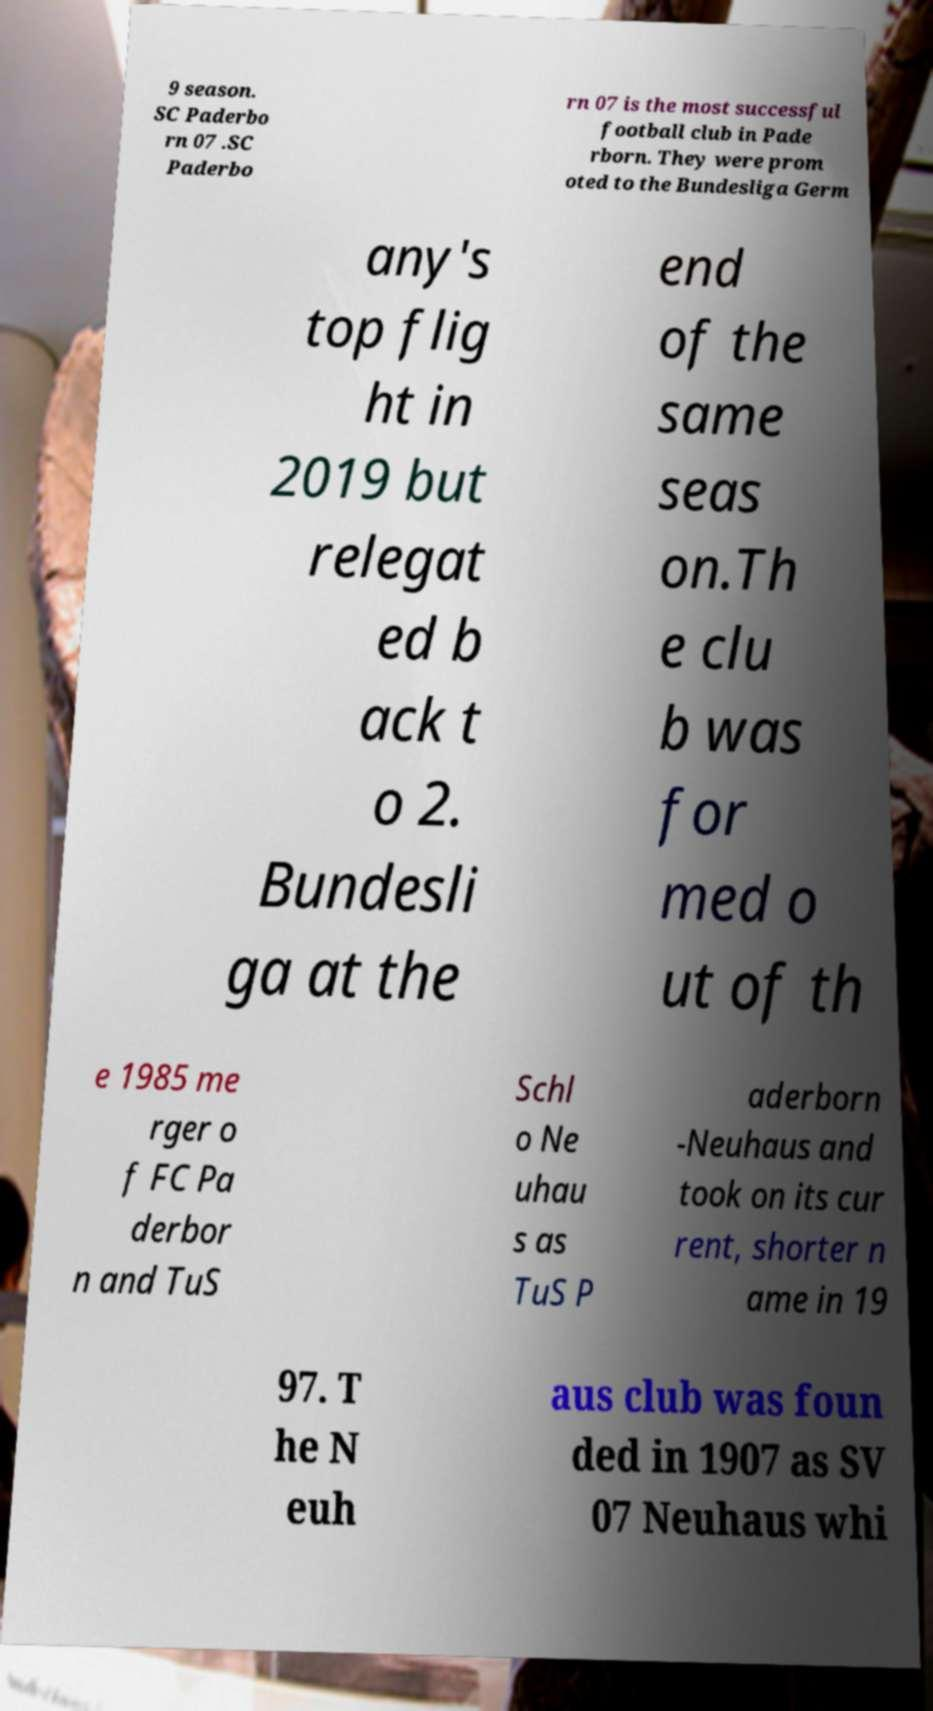Can you accurately transcribe the text from the provided image for me? 9 season. SC Paderbo rn 07 .SC Paderbo rn 07 is the most successful football club in Pade rborn. They were prom oted to the Bundesliga Germ any's top flig ht in 2019 but relegat ed b ack t o 2. Bundesli ga at the end of the same seas on.Th e clu b was for med o ut of th e 1985 me rger o f FC Pa derbor n and TuS Schl o Ne uhau s as TuS P aderborn -Neuhaus and took on its cur rent, shorter n ame in 19 97. T he N euh aus club was foun ded in 1907 as SV 07 Neuhaus whi 